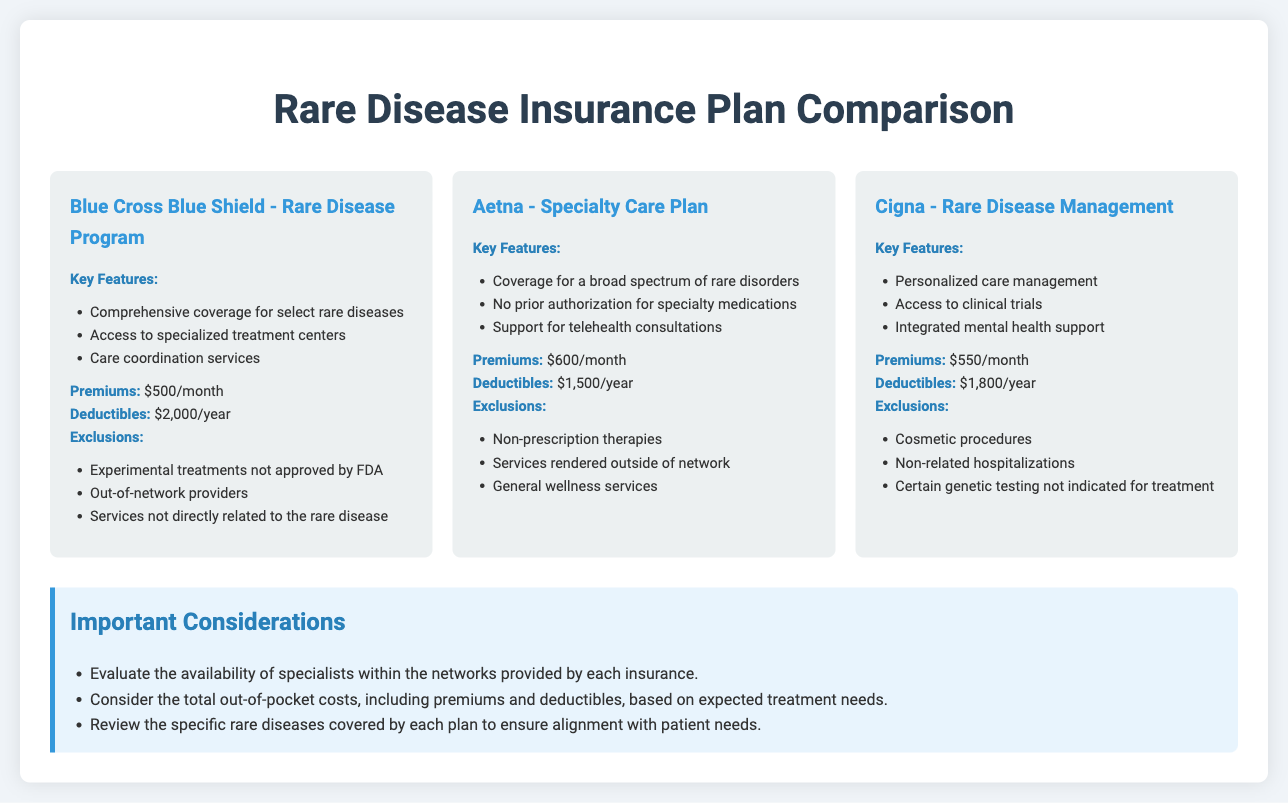What is the premium for the Blue Cross Blue Shield plan? The premium for the Blue Cross Blue Shield plan is listed directly under premiums.
Answer: $500/month What key feature is unique to Aetna's Specialty Care Plan? The unique aspect of Aetna's plan is highlighted in the key features section, mentioning no prior authorization for specialty medications.
Answer: No prior authorization for specialty medications What are the exclusions for Cigna's Rare Disease Management plan? The exclusions for Cigna's plan are explicitly listed under exclusions.
Answer: Cosmetic procedures, Non-related hospitalizations, Certain genetic testing not indicated for treatment How much is the deductible for Aetna's plan? The deductible amount for Aetna's plan is provided under deductibles.
Answer: $1,500/year Which insurance plan covers the lowest premium? The premium amounts for each plan allow for easy comparison to identify the lowest.
Answer: Blue Cross Blue Shield - $500/month What total out-of-pocket costs should prospective patients consider? The document mentions considering total out-of-pocket costs based on premiums and deductibles for treatment needs.
Answer: Total out-of-pocket costs, including premiums and deductibles How many plans are compared in this document? The number of plans is evident from the grid layout, showing three distinct plans.
Answer: Three plans What type of services does the Blue Cross Blue Shield plan provide access to? The plan details mention access to specialized treatment centers and care coordination services.
Answer: Specialized treatment centers Which plan offers integrated mental health support? This information is outlined in the key features of the plans, specifically for Cigna.
Answer: Cigna - Rare Disease Management 